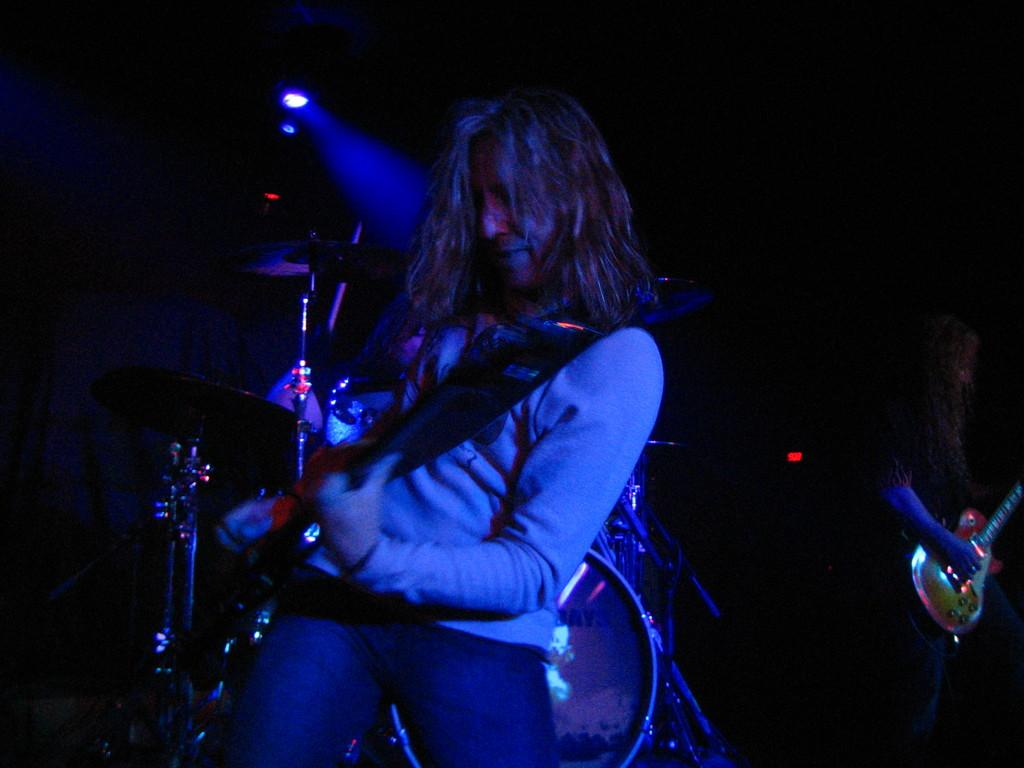What is the person in the image doing? The person is playing the guitar. What type of clothing is the person wearing on their upper body? The person is wearing a sweater. What type of clothing is the person wearing on their lower body? The person is wearing trousers. What can be seen in the middle of the image? There are focused lights in the middle of the image. What type of crown is the person wearing in the image? There is no crown present in the image; the person is wearing a sweater and trousers. 